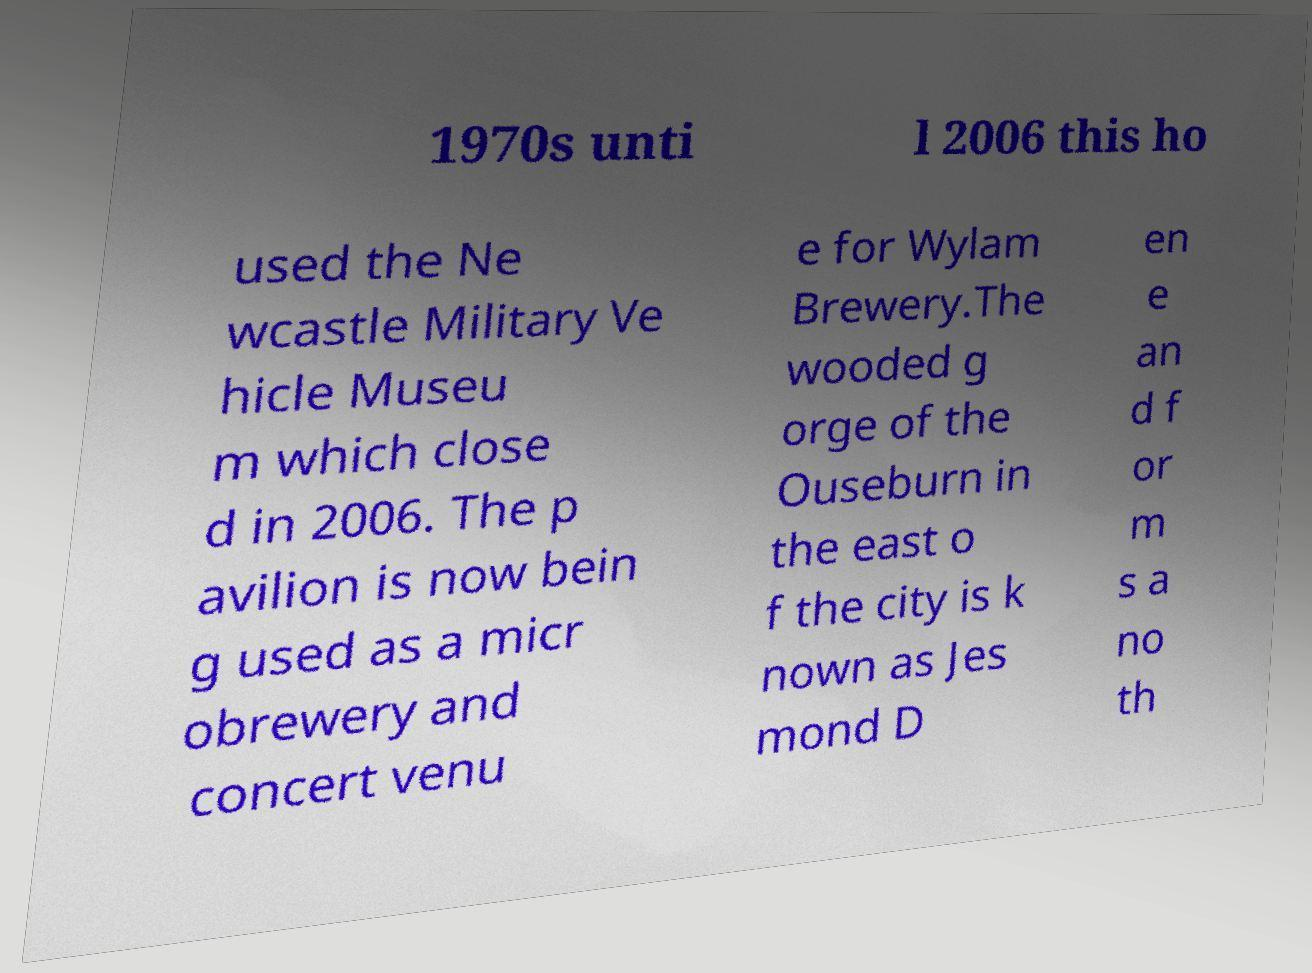Please identify and transcribe the text found in this image. 1970s unti l 2006 this ho used the Ne wcastle Military Ve hicle Museu m which close d in 2006. The p avilion is now bein g used as a micr obrewery and concert venu e for Wylam Brewery.The wooded g orge of the Ouseburn in the east o f the city is k nown as Jes mond D en e an d f or m s a no th 